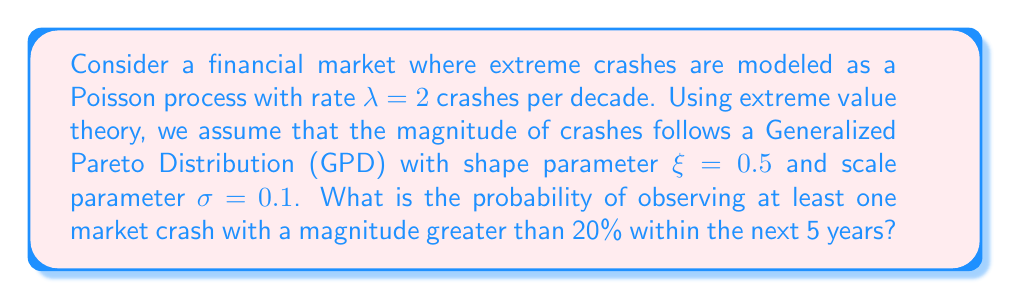Can you answer this question? Let's approach this step-by-step:

1) First, we need to calculate the probability of a crash exceeding 20% magnitude, given that a crash occurs. Using the GPD cumulative distribution function:

   $P(X > x | X > u) = \left(1 + \xi\frac{x-u}{\sigma}\right)^{-1/\xi}$

   Where $u = 0$ (we're considering all crashes), $x = 0.2$ (20% magnitude), $\xi = 0.5$, and $\sigma = 0.1$

   $P(X > 0.2) = \left(1 + 0.5\frac{0.2-0}{0.1}\right)^{-1/0.5} = (1 + 1)^{-2} = \frac{1}{4}$

2) Now, we need to calculate the expected number of crashes in 5 years. Given $\lambda = 2$ per decade:

   $\lambda_{5years} = 2 \times \frac{5}{10} = 1$

3) The probability of at least one crash exceeding 20% in 5 years is the complement of the probability of no such crashes. We can model this using a Poisson process:

   $P(\text{at least one crash > 20%}) = 1 - P(\text{no crashes > 20%})$

   $= 1 - e^{-\lambda_{5years} \times P(X > 0.2)}$

   $= 1 - e^{-1 \times \frac{1}{4}}$

   $= 1 - e^{-0.25}$

   $= 1 - 0.7788$

   $= 0.2212$

Therefore, the probability of observing at least one market crash with a magnitude greater than 20% within the next 5 years is approximately 0.2212 or 22.12%.
Answer: 0.2212 